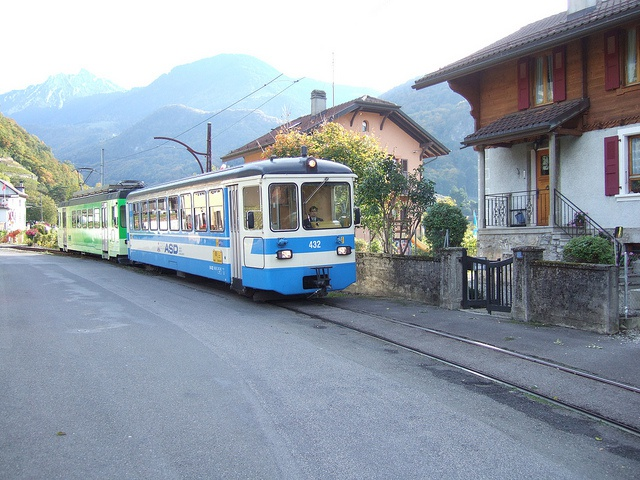Describe the objects in this image and their specific colors. I can see train in white, lightgray, gray, darkgray, and black tones and people in white, gray, and black tones in this image. 